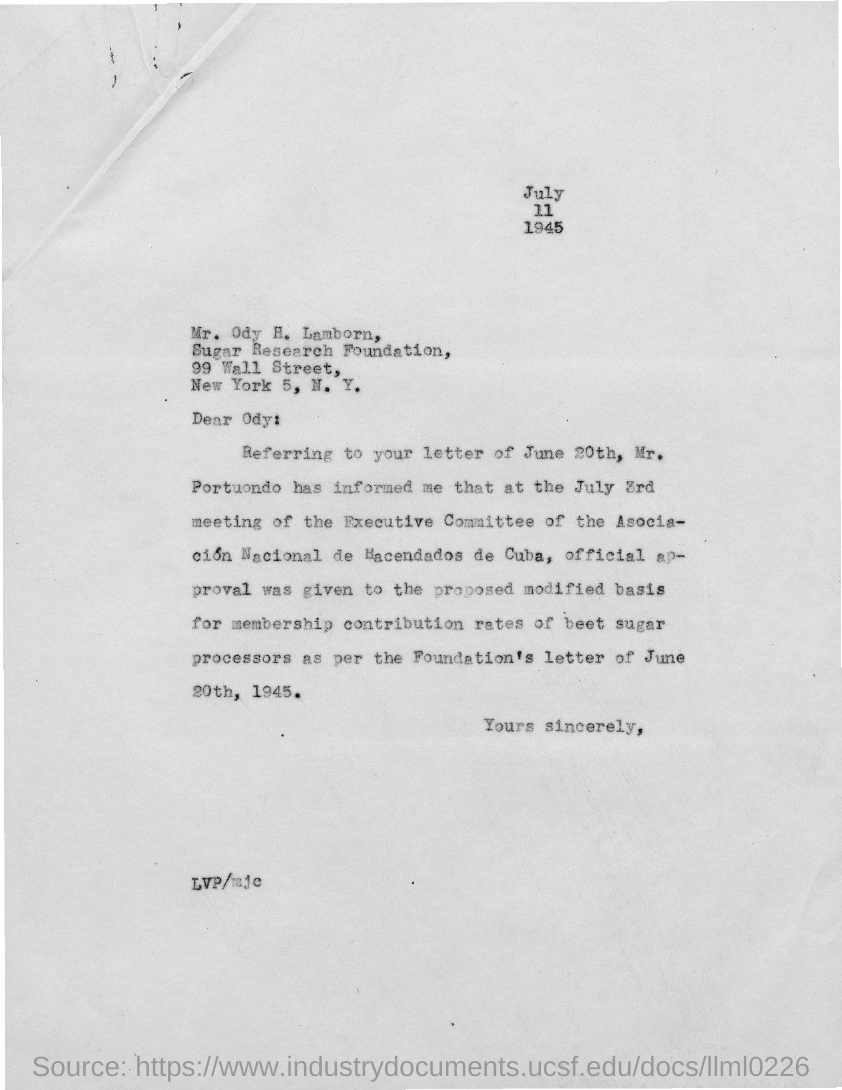Highlight a few significant elements in this photo. The Sugar Research Foundation is the name of the foundation mentioned in the given letter. The letter was written to the person or entity named "Odysseus. The street mentioned in the given letter is 99 Wall Street. The given letter mentions the year 1945. 